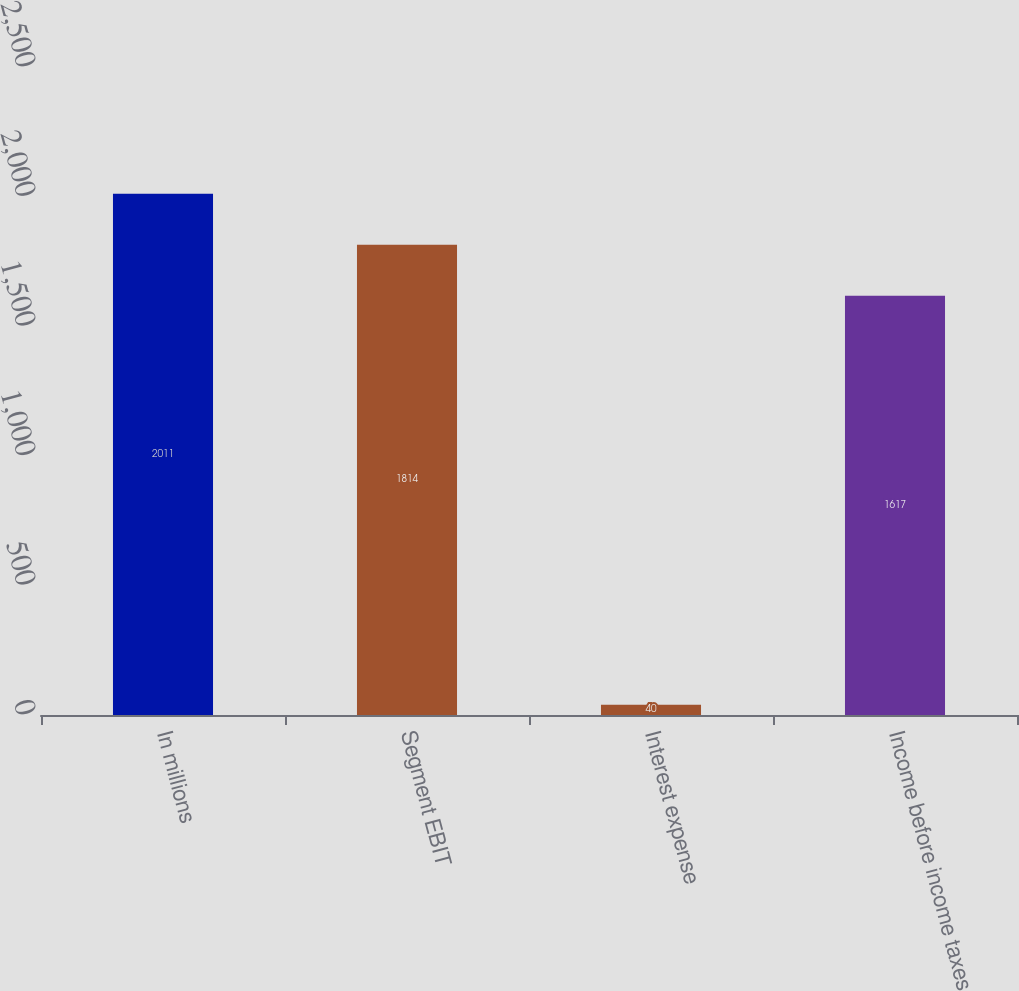<chart> <loc_0><loc_0><loc_500><loc_500><bar_chart><fcel>In millions<fcel>Segment EBIT<fcel>Interest expense<fcel>Income before income taxes<nl><fcel>2011<fcel>1814<fcel>40<fcel>1617<nl></chart> 